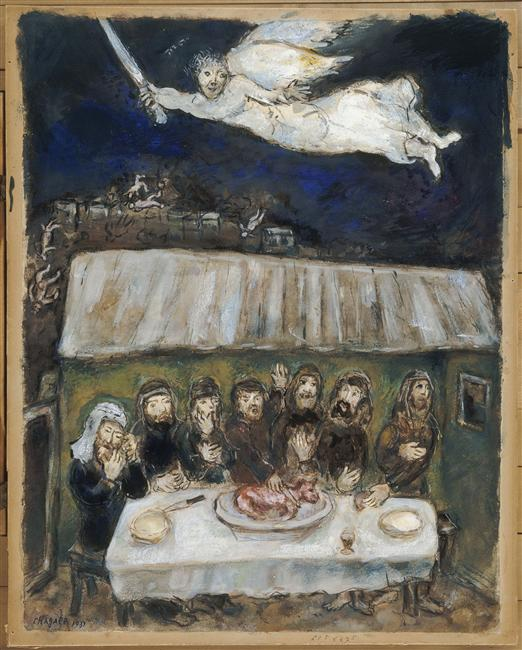What are the emotions conveyed by the people in this image? The people in the image convey a range of emotions, predominantly solemnity and contemplation. They appear deeply engaged with the scene, with their expressions suggesting a moment of profound significance. There is a sense of unity and collective attention among the group, possibly indicating shared concern or reverence. 